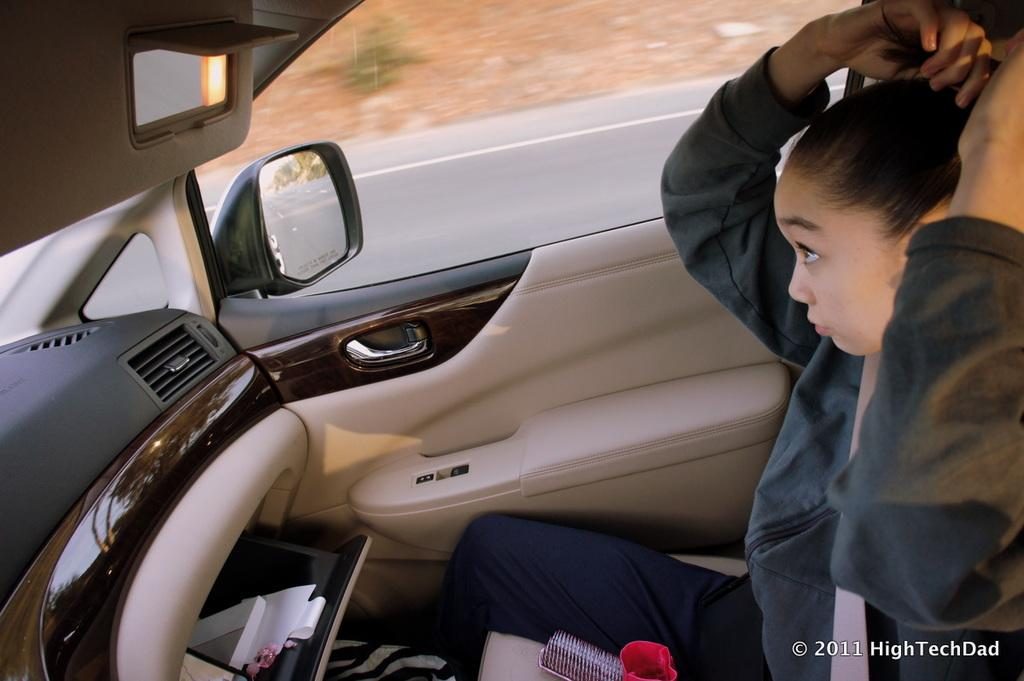Where was the picture taken? The picture was taken inside a car. Who is present in the car? There is a woman sitting in the car. What items can be seen in the car? There is a comb, papers, and other objects in the car. What feature is present on the car? There is a side mirror on the car. What is the opinion of the snails on the car's interior design? There are no snails present in the image, so it is not possible to determine their opinion on the car's interior design. 